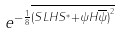<formula> <loc_0><loc_0><loc_500><loc_500>e ^ { - \frac { 1 } { 8 } \overline { { ( { S L H S ^ { * } } + { \psi H \overline { \psi } } ) } ^ { 2 } } }</formula> 